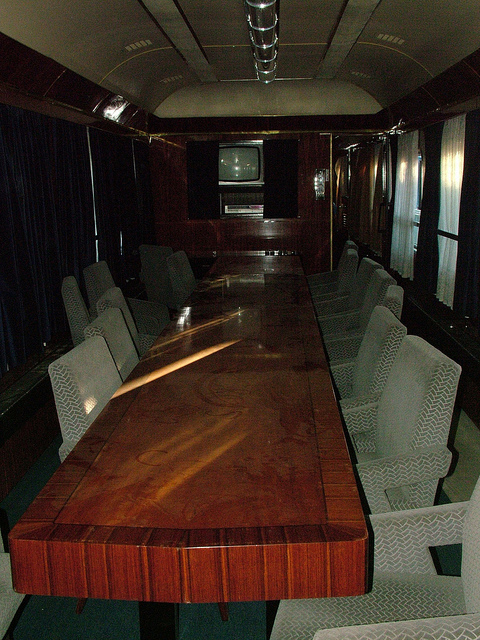<image>What city is this in? It is ambiguous what city this is in. The possibilities include New York, Louisville, Chicago, Las Vegas, Berlin, and Atlanta. What city is this in? I don't know what city this is in. It could be New York, Louisville, Chicago, Las Vegas, Berlin, or Atlanta. 